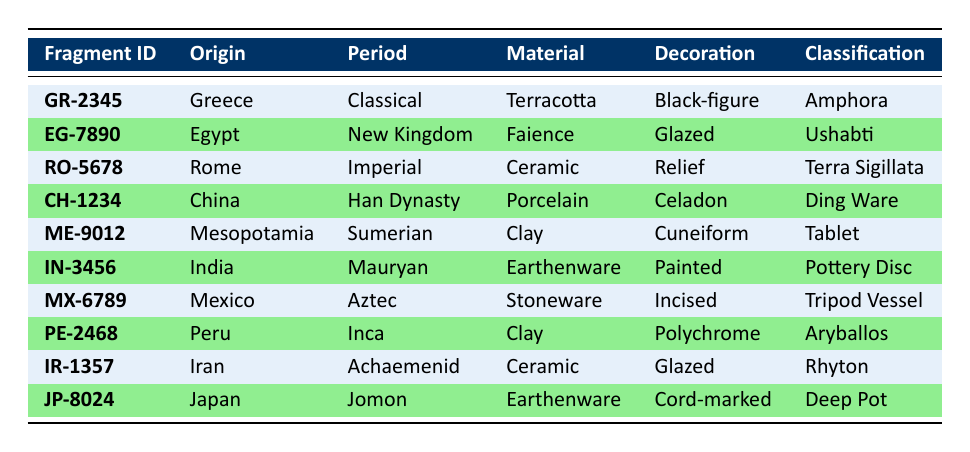What is the origin of the fragment with ID GR-2345? By looking at the row corresponding to the Fragment ID GR-2345 in the table, the Origin column shows "Greece."
Answer: Greece Which materials are used in the pottery fragments from the New Kingdom period? Referring to the second row, the material used for the fragment from the New Kingdom is "Faience." There's only one fragment from that period listed in the table.
Answer: Faience Is there a fragment classified as Rhyton? The table shows a fragment with the Classification "Rhyton" in the row with Fragment ID IR-1357, indicating that such a fragment exists.
Answer: Yes What is the decoration style of the Tripod Vessel? Looking at the row for Fragment ID MX-6789, it indicates that the Decoration is "Incised."
Answer: Incised Which periods have fragments made of Ceramic? The table shows two rows for fragments made of Ceramic: one is from the Imperial period (Fragment ID RO-5678) and the other from the Achaemenid period (Fragment ID IR-1357). Therefore, the periods are Imperial and Achaemenid.
Answer: Imperial, Achaemenid How many different classification types are listed in this dataset? Searching through the Classification column reveals unique classifications: Amphora, Ushabti, Terra Sigillata, Ding Ware, Tablet, Pottery Disc, Tripod Vessel, Aryballos, Rhyton, and Deep Pot, totaling 10 unique classifications.
Answer: 10 Are there any pottery fragments made of Islamic influence? By examining the table, there are no entries or classifications that mention Islamic influence; it only covers cultures from Greece to Japan.
Answer: No Which fragment has the earliest origin mentioned in the table? The ancient civilization of Mesopotamia is often considered one of the earliest, among the entries listed, and it has the fragment ME-9012 noted in the Sumerian period, supporting this conclusion.
Answer: Mesopotamia 